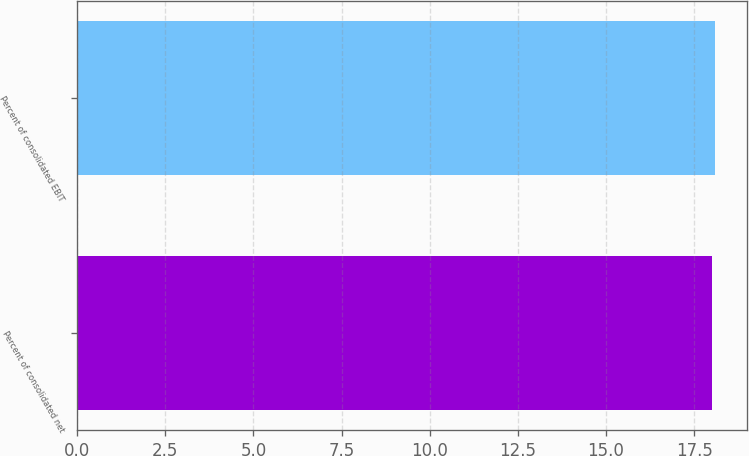<chart> <loc_0><loc_0><loc_500><loc_500><bar_chart><fcel>Percent of consolidated net<fcel>Percent of consolidated EBIT<nl><fcel>18<fcel>18.1<nl></chart> 